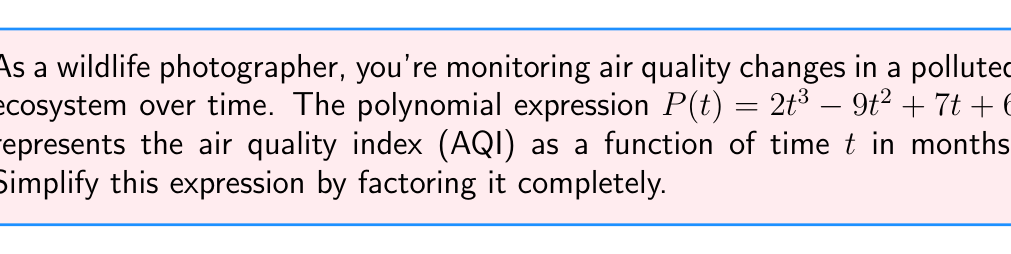Teach me how to tackle this problem. Let's approach this step-by-step:

1) First, we need to check if there are any common factors. In this case, there are none, so we proceed to the next step.

2) This is a cubic polynomial. One method to factor it is to guess one root and then use polynomial long division.

3) Let's try some potential roots. The possible rational roots are the factors of the constant term: ±1, ±2, ±3, ±6.

4) Testing these, we find that $t = -1$ is a root. So $(t+1)$ is a factor.

5) Let's use polynomial long division to divide $P(t)$ by $(t+1)$:

   $$\frac{2t^3 - 9t^2 + 7t + 6}{t + 1} = 2t^2 - 11t + 18$$

6) So now we have: $P(t) = (t+1)(2t^2 - 11t + 18)$

7) The quadratic factor $2t^2 - 11t + 18$ can be factored further:
   
   $2t^2 - 11t + 18 = (2t - 9)(t - 2)$

8) Therefore, the complete factorization is:

   $P(t) = (t+1)(2t - 9)(t - 2)$

This factored form represents the air quality changes more clearly, showing the specific time points (at $t = -1$, $t = 4.5$, and $t = 2$) where the AQI crosses the zero threshold.
Answer: $(t+1)(2t - 9)(t - 2)$ 